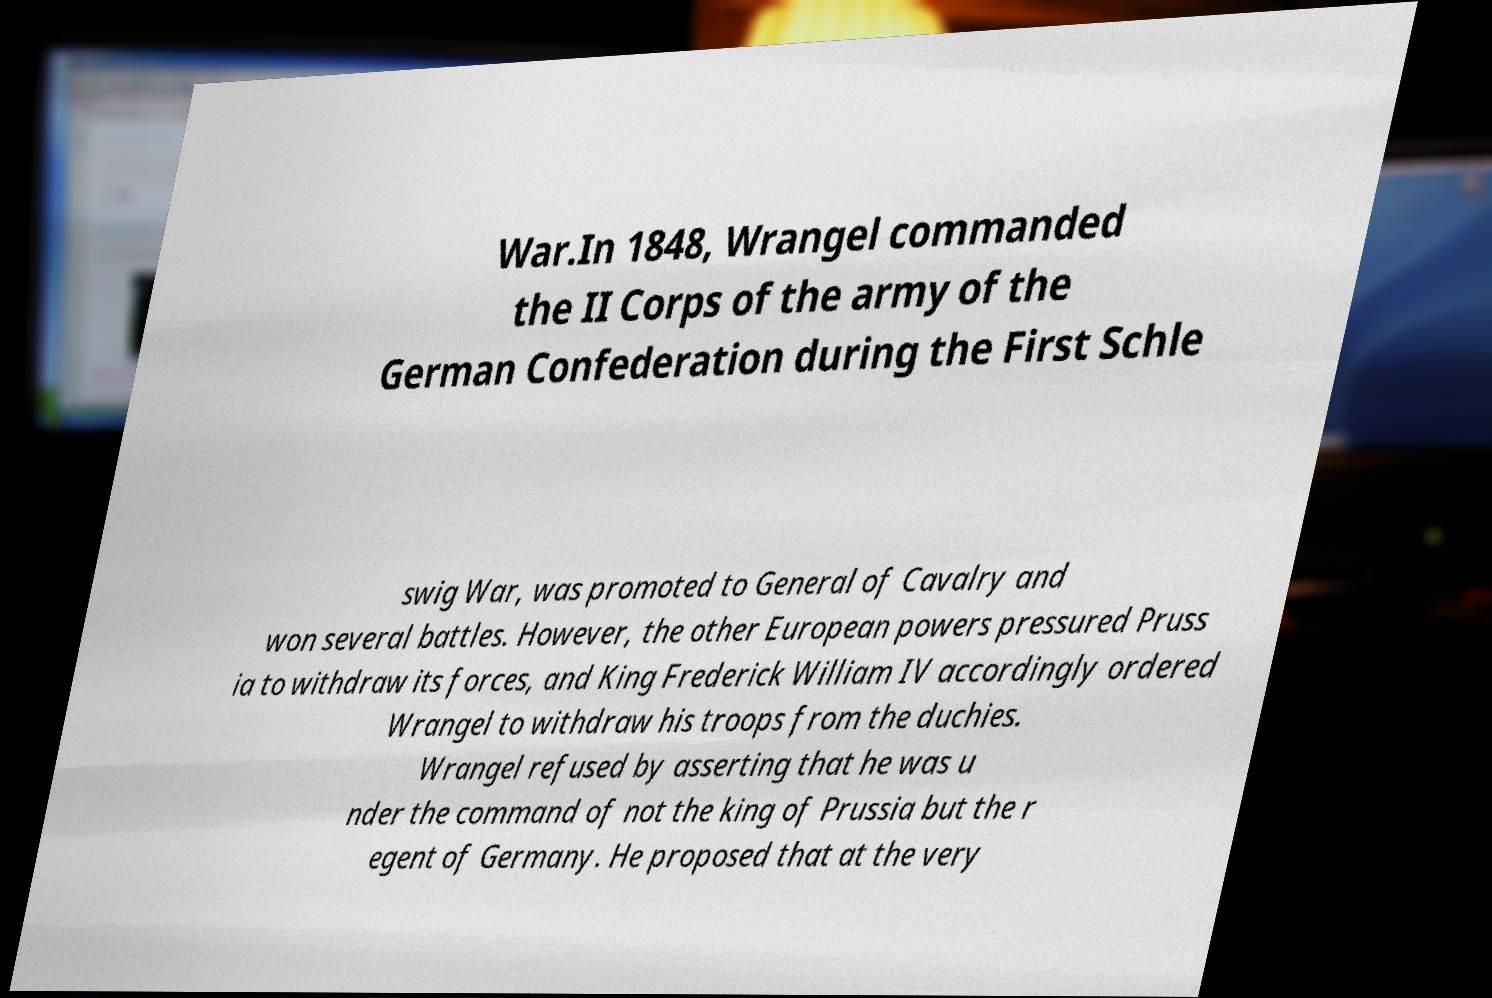What messages or text are displayed in this image? I need them in a readable, typed format. War.In 1848, Wrangel commanded the II Corps of the army of the German Confederation during the First Schle swig War, was promoted to General of Cavalry and won several battles. However, the other European powers pressured Pruss ia to withdraw its forces, and King Frederick William IV accordingly ordered Wrangel to withdraw his troops from the duchies. Wrangel refused by asserting that he was u nder the command of not the king of Prussia but the r egent of Germany. He proposed that at the very 